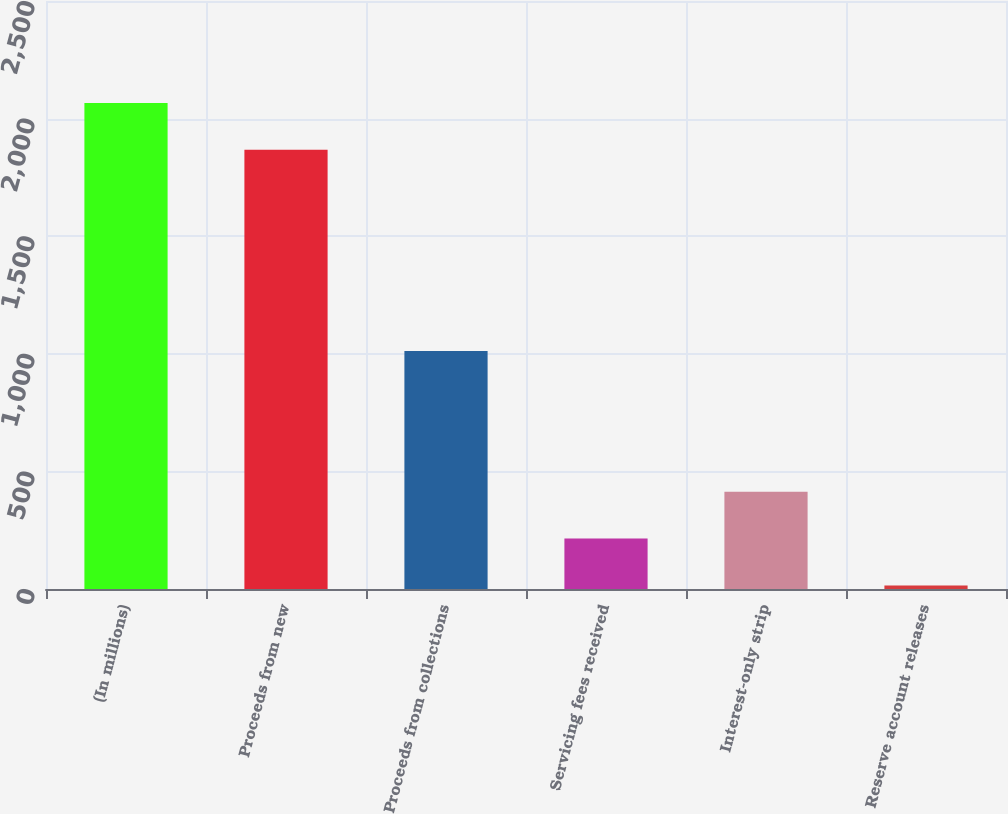Convert chart to OTSL. <chart><loc_0><loc_0><loc_500><loc_500><bar_chart><fcel>(In millions)<fcel>Proceeds from new<fcel>Proceeds from collections<fcel>Servicing fees received<fcel>Interest-only strip<fcel>Reserve account releases<nl><fcel>2066.68<fcel>1867.5<fcel>1011.8<fcel>214.38<fcel>413.56<fcel>15.2<nl></chart> 